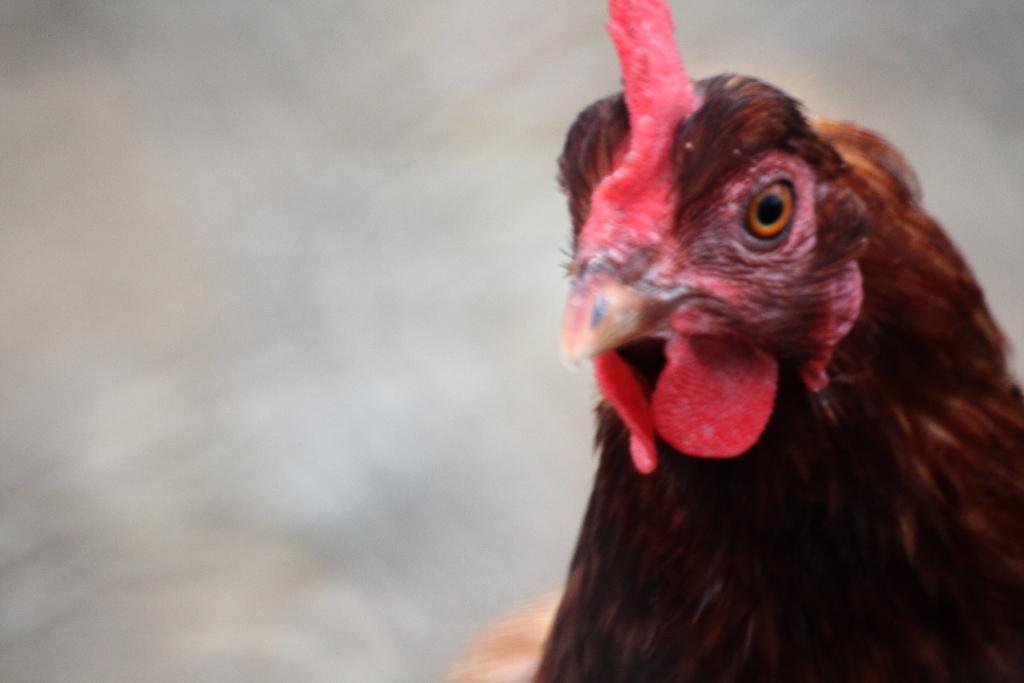How would you summarize this image in a sentence or two? In this image, I can see the face of a hen. The background looks blurry. 